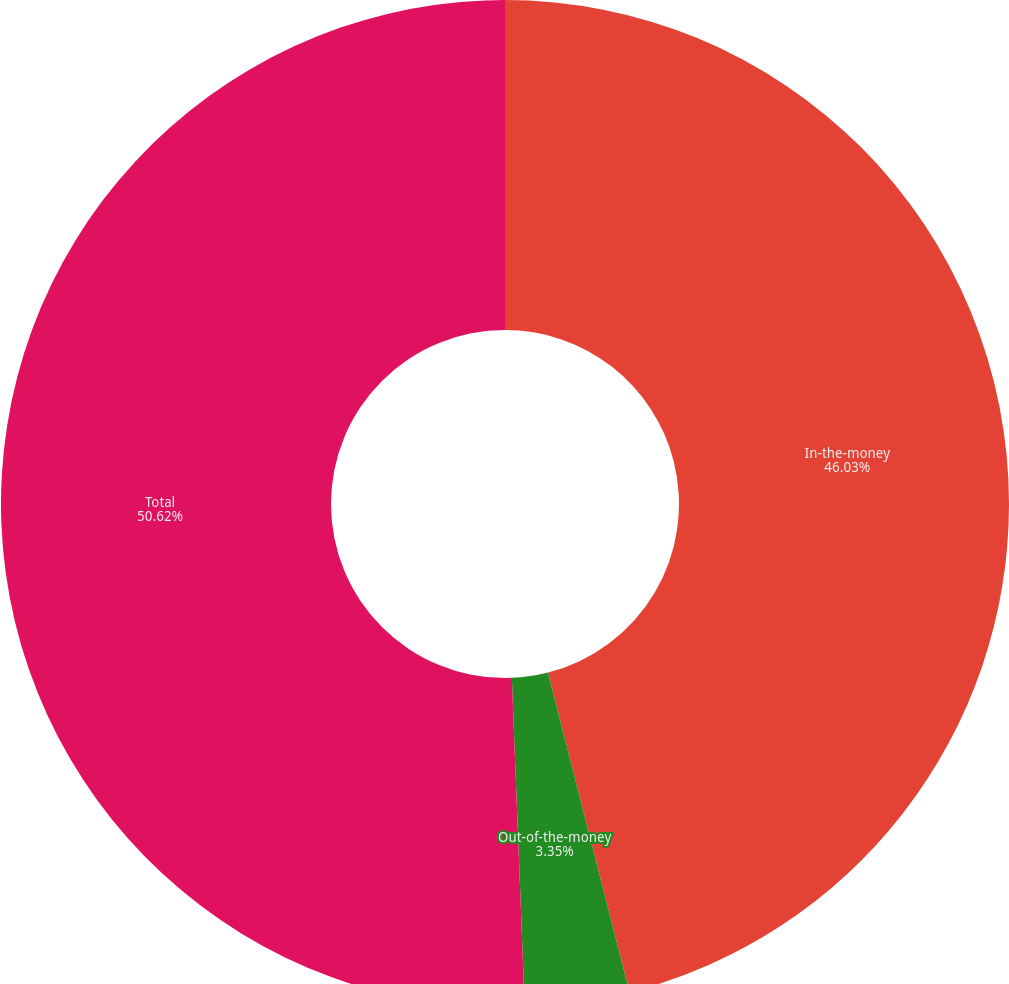<chart> <loc_0><loc_0><loc_500><loc_500><pie_chart><fcel>In-the-money<fcel>Out-of-the-money<fcel>Total<nl><fcel>46.03%<fcel>3.35%<fcel>50.63%<nl></chart> 